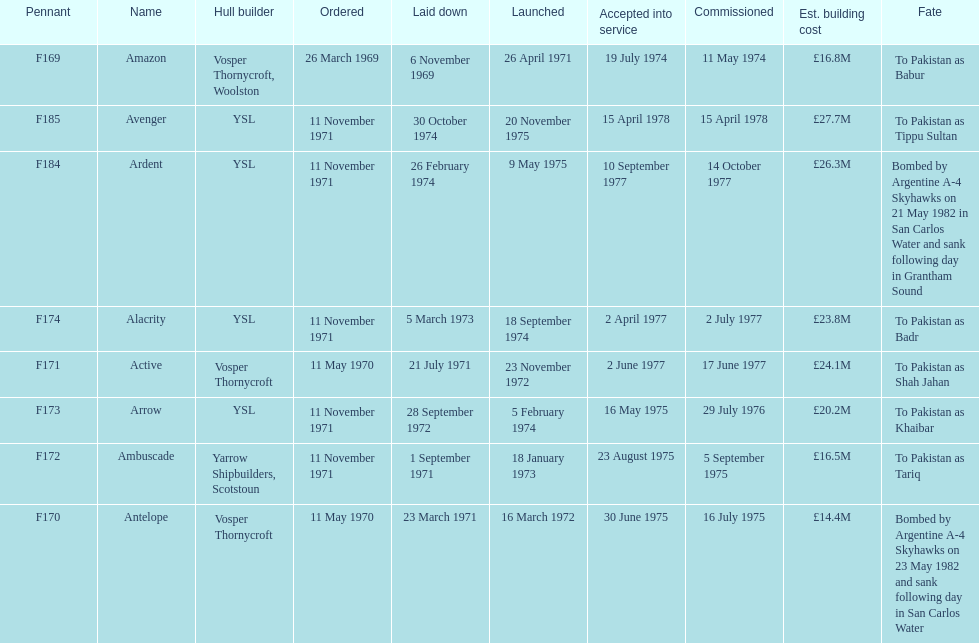What were the estimated building costs of the frigates? £16.8M, £14.4M, £16.5M, £20.2M, £24.1M, £23.8M, £26.3M, £27.7M. Which of these is the largest? £27.7M. What ship name does that correspond to? Avenger. 